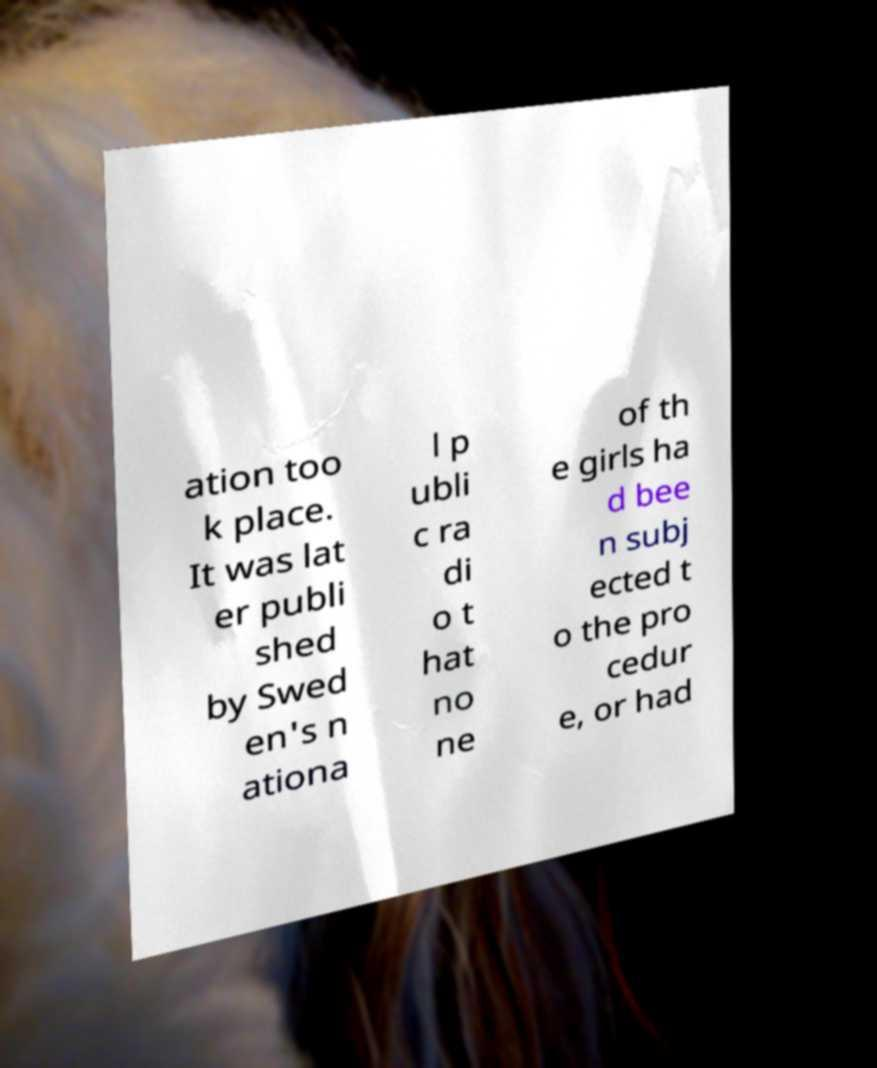I need the written content from this picture converted into text. Can you do that? ation too k place. It was lat er publi shed by Swed en's n ationa l p ubli c ra di o t hat no ne of th e girls ha d bee n subj ected t o the pro cedur e, or had 